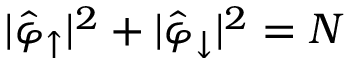<formula> <loc_0><loc_0><loc_500><loc_500>| \hat { \varphi } _ { \uparrow } | ^ { 2 } + | \hat { \varphi } _ { \downarrow } | ^ { 2 } = N</formula> 